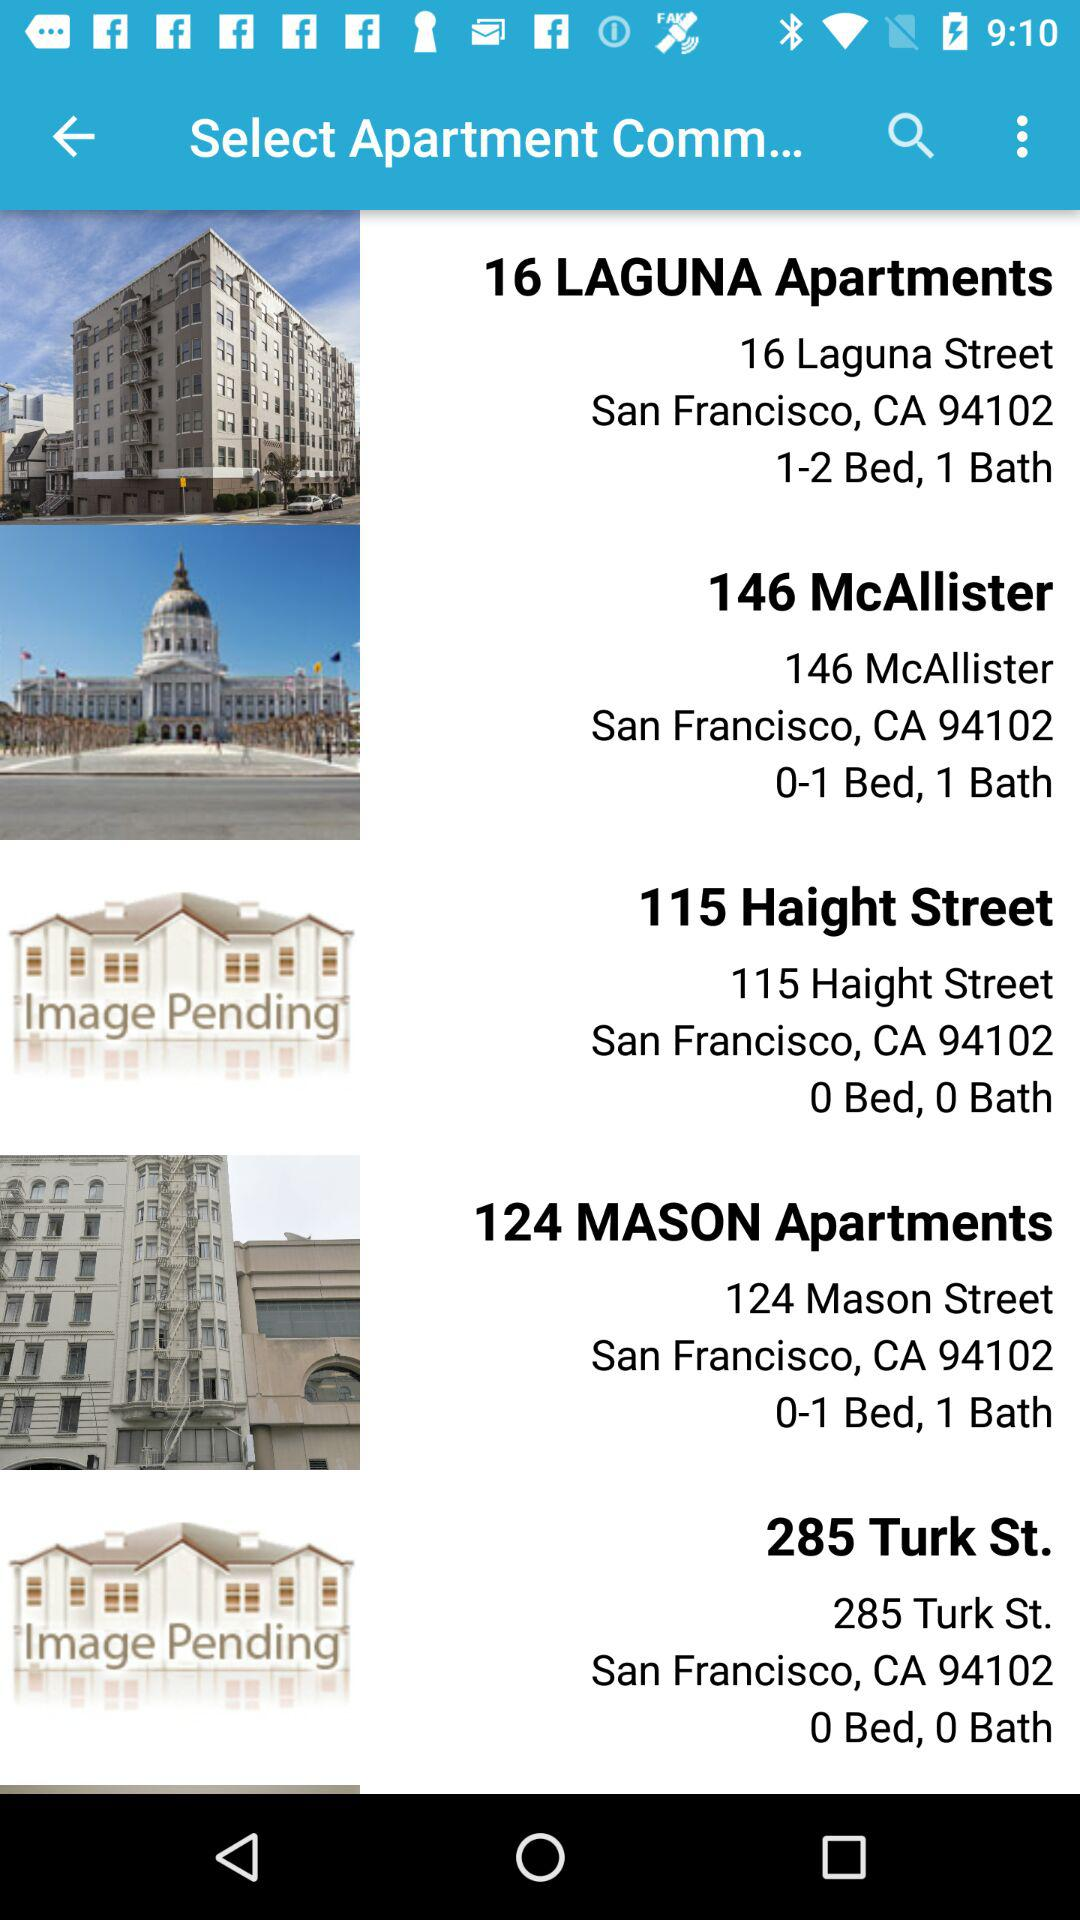How many bath are there in the "124 MASON Apartments"? There is 1 bath. 